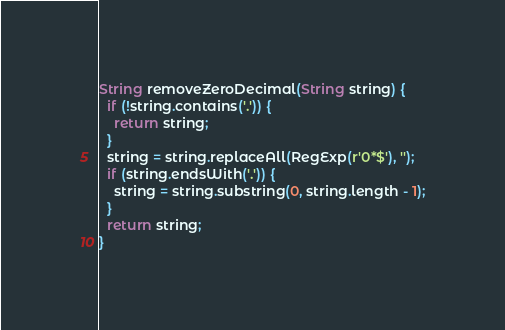<code> <loc_0><loc_0><loc_500><loc_500><_Dart_>String removeZeroDecimal(String string) {
  if (!string.contains('.')) {
    return string;
  }
  string = string.replaceAll(RegExp(r'0*$'), '');
  if (string.endsWith('.')) {
    string = string.substring(0, string.length - 1);
  }
  return string;
}
</code> 